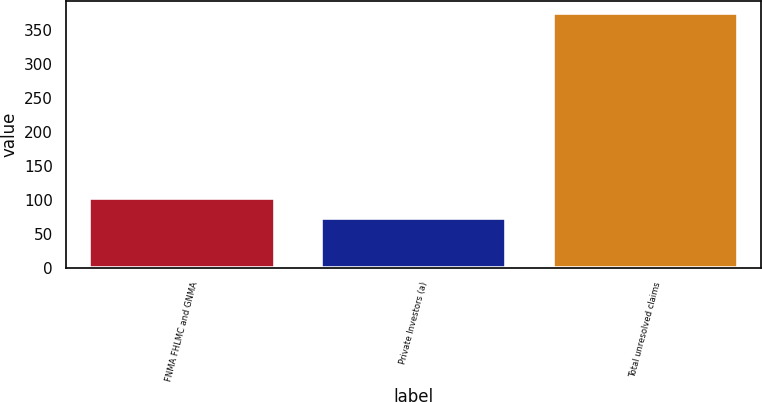Convert chart. <chart><loc_0><loc_0><loc_500><loc_500><bar_chart><fcel>FNMA FHLMC and GNMA<fcel>Private Investors (a)<fcel>Total unresolved claims<nl><fcel>103.2<fcel>73<fcel>375<nl></chart> 